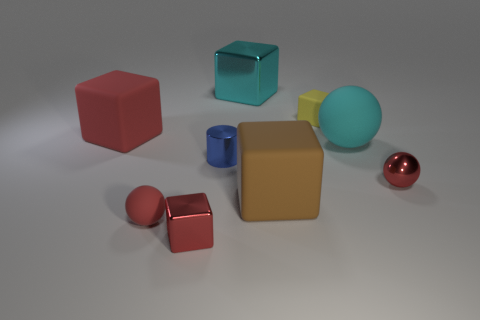Subtract all red metallic cubes. How many cubes are left? 4 Subtract 1 cubes. How many cubes are left? 4 Subtract all brown blocks. How many blocks are left? 4 Subtract all cyan blocks. Subtract all brown cylinders. How many blocks are left? 4 Subtract all cubes. How many objects are left? 4 Subtract all big blue metal cylinders. Subtract all big cyan spheres. How many objects are left? 8 Add 8 red blocks. How many red blocks are left? 10 Add 1 tiny brown shiny blocks. How many tiny brown shiny blocks exist? 1 Subtract 0 yellow spheres. How many objects are left? 9 